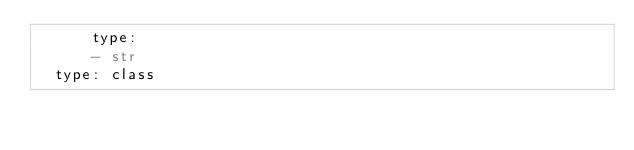<code> <loc_0><loc_0><loc_500><loc_500><_YAML_>      type:
      - str
  type: class</code> 